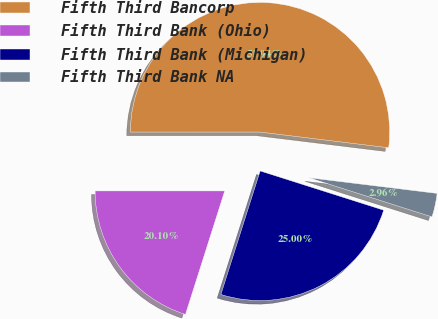Convert chart to OTSL. <chart><loc_0><loc_0><loc_500><loc_500><pie_chart><fcel>Fifth Third Bancorp<fcel>Fifth Third Bank (Ohio)<fcel>Fifth Third Bank (Michigan)<fcel>Fifth Third Bank NA<nl><fcel>51.93%<fcel>20.1%<fcel>25.0%<fcel>2.96%<nl></chart> 